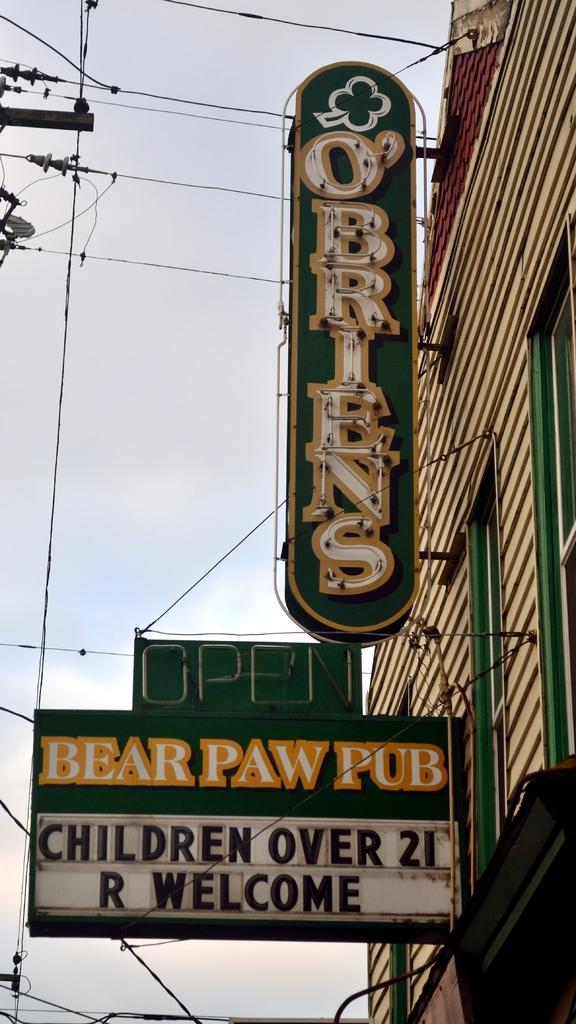What type of structure is present in the image? There is a building in the image. What can be seen on the building? There are boards with text on the building. What else is visible in the image besides the building? Electric wires are visible in the image. What is visible in the background of the image? The sky is visible in the image. What type of feast is being prepared in the image? There is no indication of a feast or any food preparation in the image. 